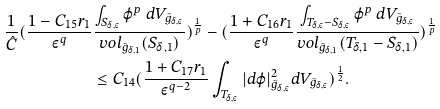Convert formula to latex. <formula><loc_0><loc_0><loc_500><loc_500>\frac { 1 } { \hat { C } } ( \frac { 1 - C _ { 1 5 } r _ { 1 } } { \varepsilon ^ { q } } & \frac { \int _ { S _ { \delta , \varepsilon } } \varphi ^ { p } \ d V _ { \tilde { g } _ { \delta , \varepsilon } } } { v o l _ { \tilde { g } _ { \delta , 1 } } ( S _ { \delta , 1 } ) } ) ^ { \frac { 1 } { p } } - ( \frac { 1 + C _ { 1 6 } r _ { 1 } } { \varepsilon ^ { q } } \frac { \int _ { T _ { \delta , \varepsilon } - S _ { \delta , \varepsilon } } \varphi ^ { p } \ d V _ { \tilde { g } _ { \delta , \varepsilon } } } { v o l _ { \tilde { g } _ { \delta , 1 } } ( T _ { \delta , 1 } - S _ { \delta , 1 } ) } ) ^ { \frac { 1 } { p } } \\ & \leq C _ { 1 4 } ( \frac { 1 + C _ { 1 7 } r _ { 1 } } { \varepsilon ^ { q - 2 } } \int _ { T _ { \delta , \varepsilon } } | d \varphi | ^ { 2 } _ { \tilde { g } _ { \delta , \varepsilon } } d V _ { \tilde { g } _ { \delta , \varepsilon } } ) ^ { \frac { 1 } { 2 } } .</formula> 